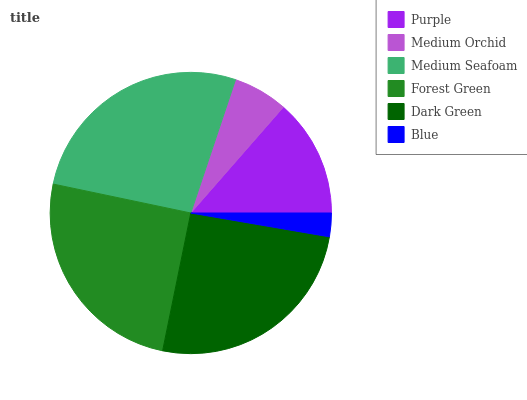Is Blue the minimum?
Answer yes or no. Yes. Is Medium Seafoam the maximum?
Answer yes or no. Yes. Is Medium Orchid the minimum?
Answer yes or no. No. Is Medium Orchid the maximum?
Answer yes or no. No. Is Purple greater than Medium Orchid?
Answer yes or no. Yes. Is Medium Orchid less than Purple?
Answer yes or no. Yes. Is Medium Orchid greater than Purple?
Answer yes or no. No. Is Purple less than Medium Orchid?
Answer yes or no. No. Is Forest Green the high median?
Answer yes or no. Yes. Is Purple the low median?
Answer yes or no. Yes. Is Purple the high median?
Answer yes or no. No. Is Blue the low median?
Answer yes or no. No. 